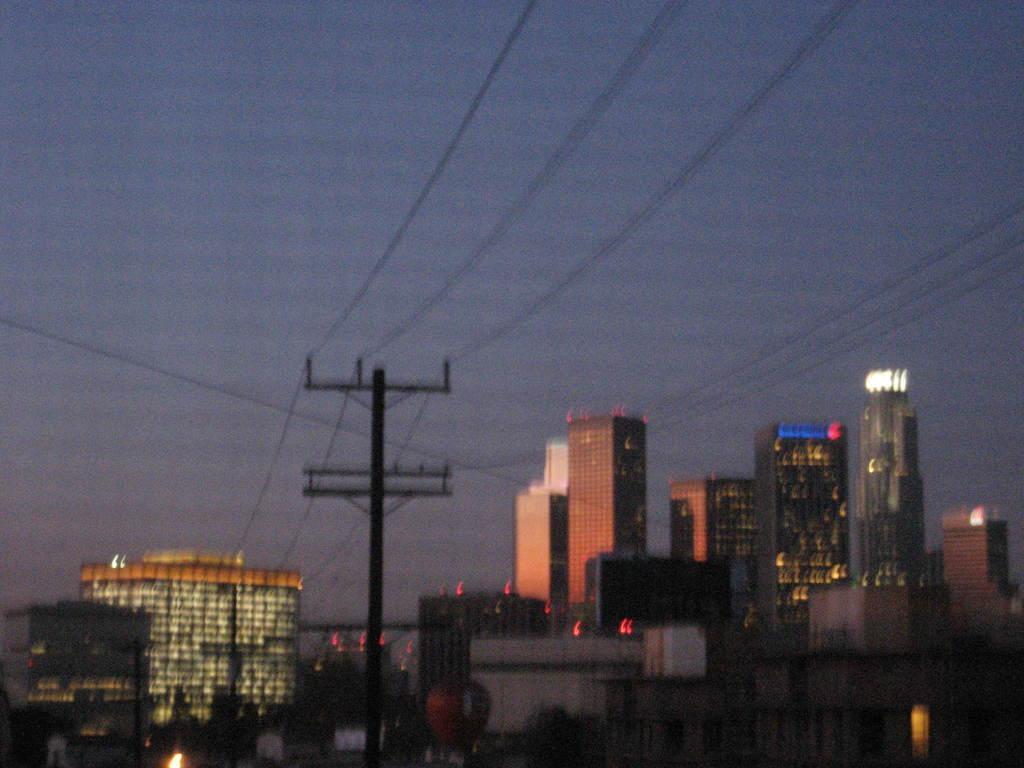Please provide a concise description of this image. In this image we can see there are buildings with lights, current polls and the sky. 